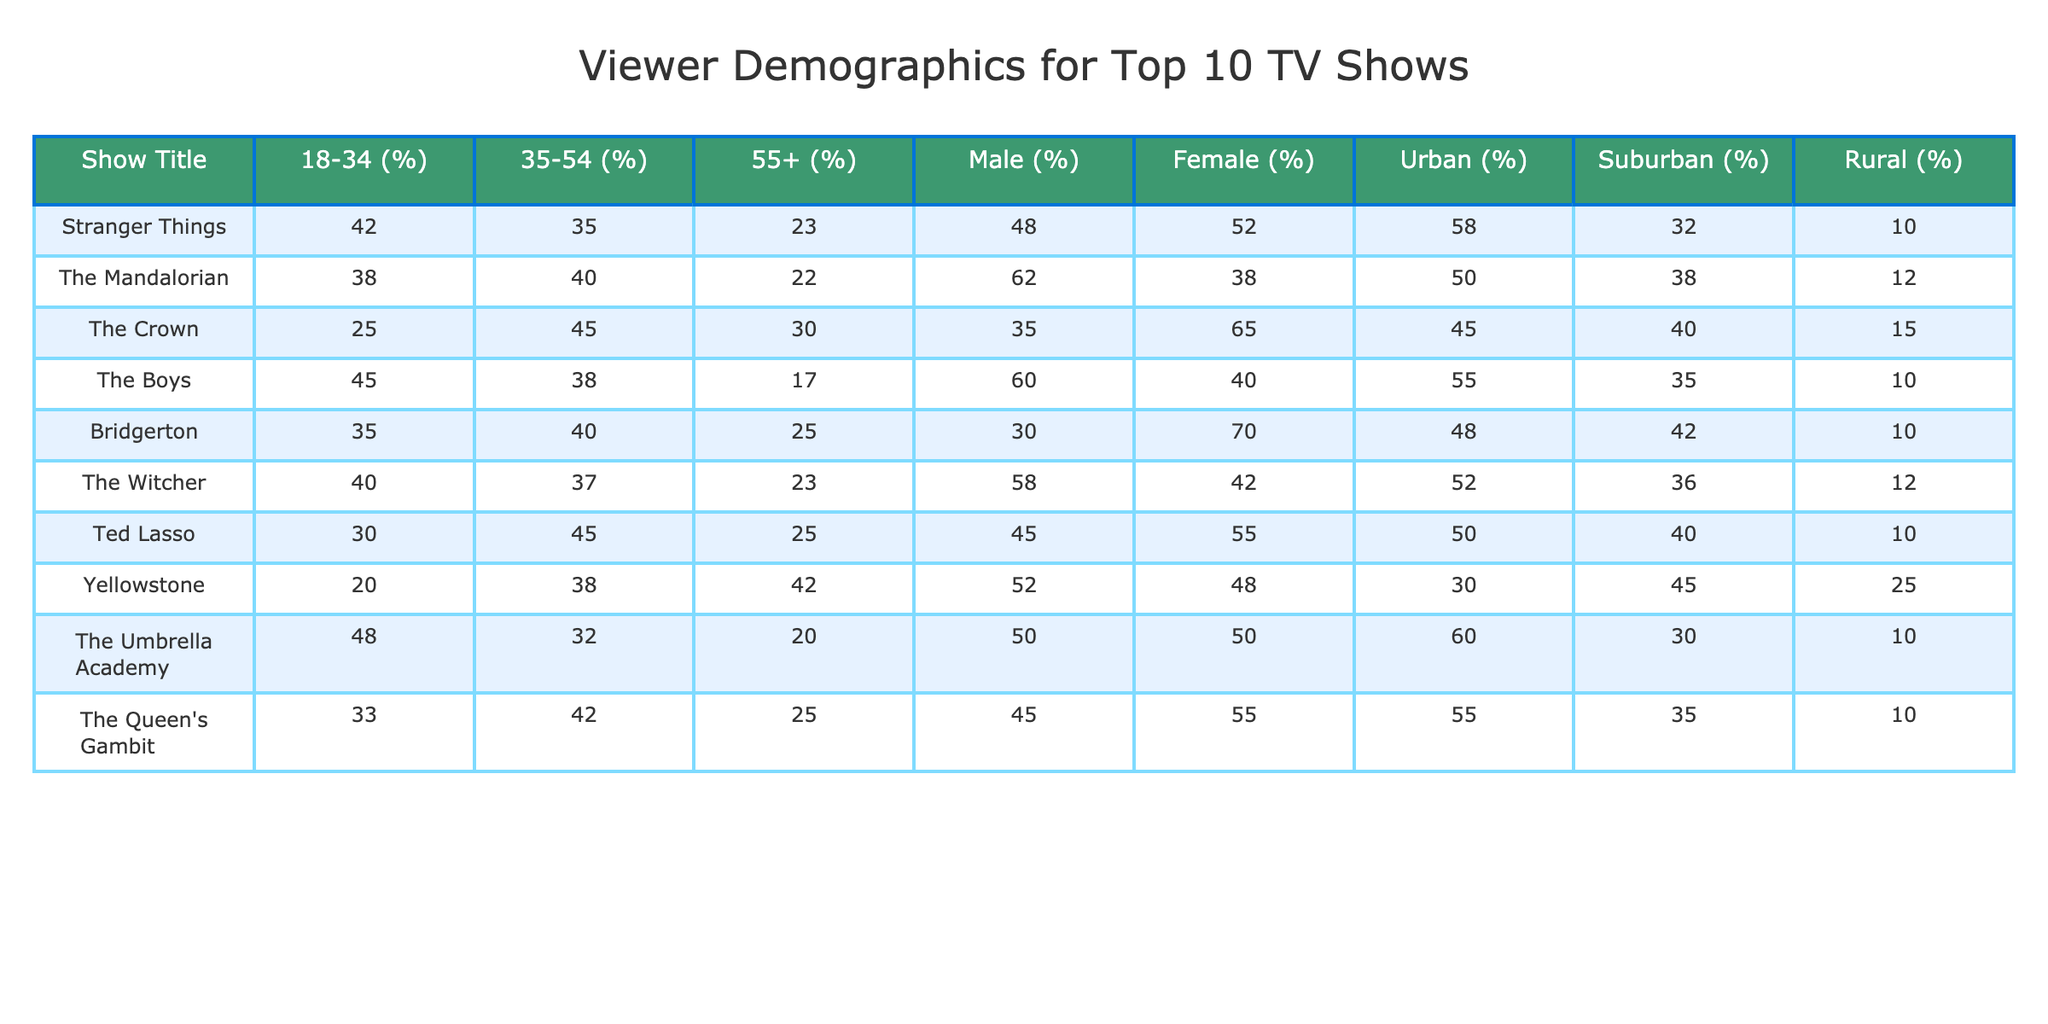What percentage of viewers for "Stranger Things" are aged 18-34? The table shows that 42% of viewers for "Stranger Things" are aged 18-34.
Answer: 42% Which show has the highest percentage of female viewers? By checking the Female (%) column, "Bridgerton" has the highest percentage of female viewers at 70%.
Answer: 70% What is the average percentage of viewers aged 55 and older across all shows? To find the average, sum the percentages for 55+ across all shows: (23 + 22 + 30 + 17 + 25 + 23 + 25 + 42 + 20 + 25) =  232. There are 10 shows, so the average is 232 / 10 = 23.2%.
Answer: 23.2% Is the percentage of rural viewers for "The Crown" higher than for "The Mandalorian"? The table indicates "The Crown" has 15% rural viewers and "The Mandalorian" has 12%. Therefore, yes, the percentage for "The Crown" is higher.
Answer: Yes Which show has the lowest percentage of viewers aged 18-34? By reviewing the 18-34 (%) column, "Yellowstone" has the lowest percentage at 20%.
Answer: 20% Calculate the difference in percentage of urban viewers between "Bridgerton" and "The Boys." "Bridgerton" has 48% urban viewers and "The Boys" has 55%. The difference is 55% - 48% = 7%.
Answer: 7% Are more viewers for "The Umbrella Academy" rural compared to "Stranger Things"? "The Umbrella Academy" has 10% rural viewers, while "Stranger Things" has 10% as well. Therefore, they are equal, not more.
Answer: No Which demographic has the highest percentage viewership for "The Witcher"? For "The Witcher," the 18-34 demographic has the highest percentage at 40% compared to 37% and 23% for the other age groups.
Answer: 18-34 Average the male viewership percentages across all shows. The male percentages are (48 + 62 + 35 + 60 + 30 + 58 + 45 + 52 + 50 + 45) =  485. Dividing by 10 gives an average of 48.5%.
Answer: 48.5% Do most shows attract a higher percentage of urban viewers compared to rural viewers? Reviewing the Urban and Rural columns, most shows have significantly higher percentages for urban versus rural. For example, "Stranger Things" has 58% urban and 10% rural, showing a consistent trend.
Answer: Yes 